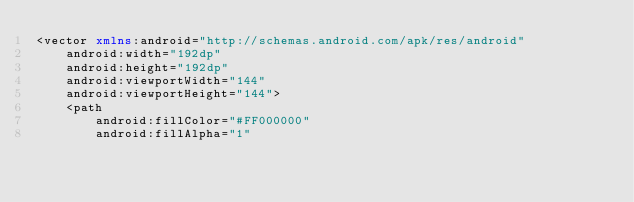<code> <loc_0><loc_0><loc_500><loc_500><_XML_><vector xmlns:android="http://schemas.android.com/apk/res/android"
    android:width="192dp"
    android:height="192dp"
    android:viewportWidth="144"
    android:viewportHeight="144">
    <path
        android:fillColor="#FF000000"
        android:fillAlpha="1"</code> 